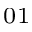Convert formula to latex. <formula><loc_0><loc_0><loc_500><loc_500>_ { 0 1 }</formula> 